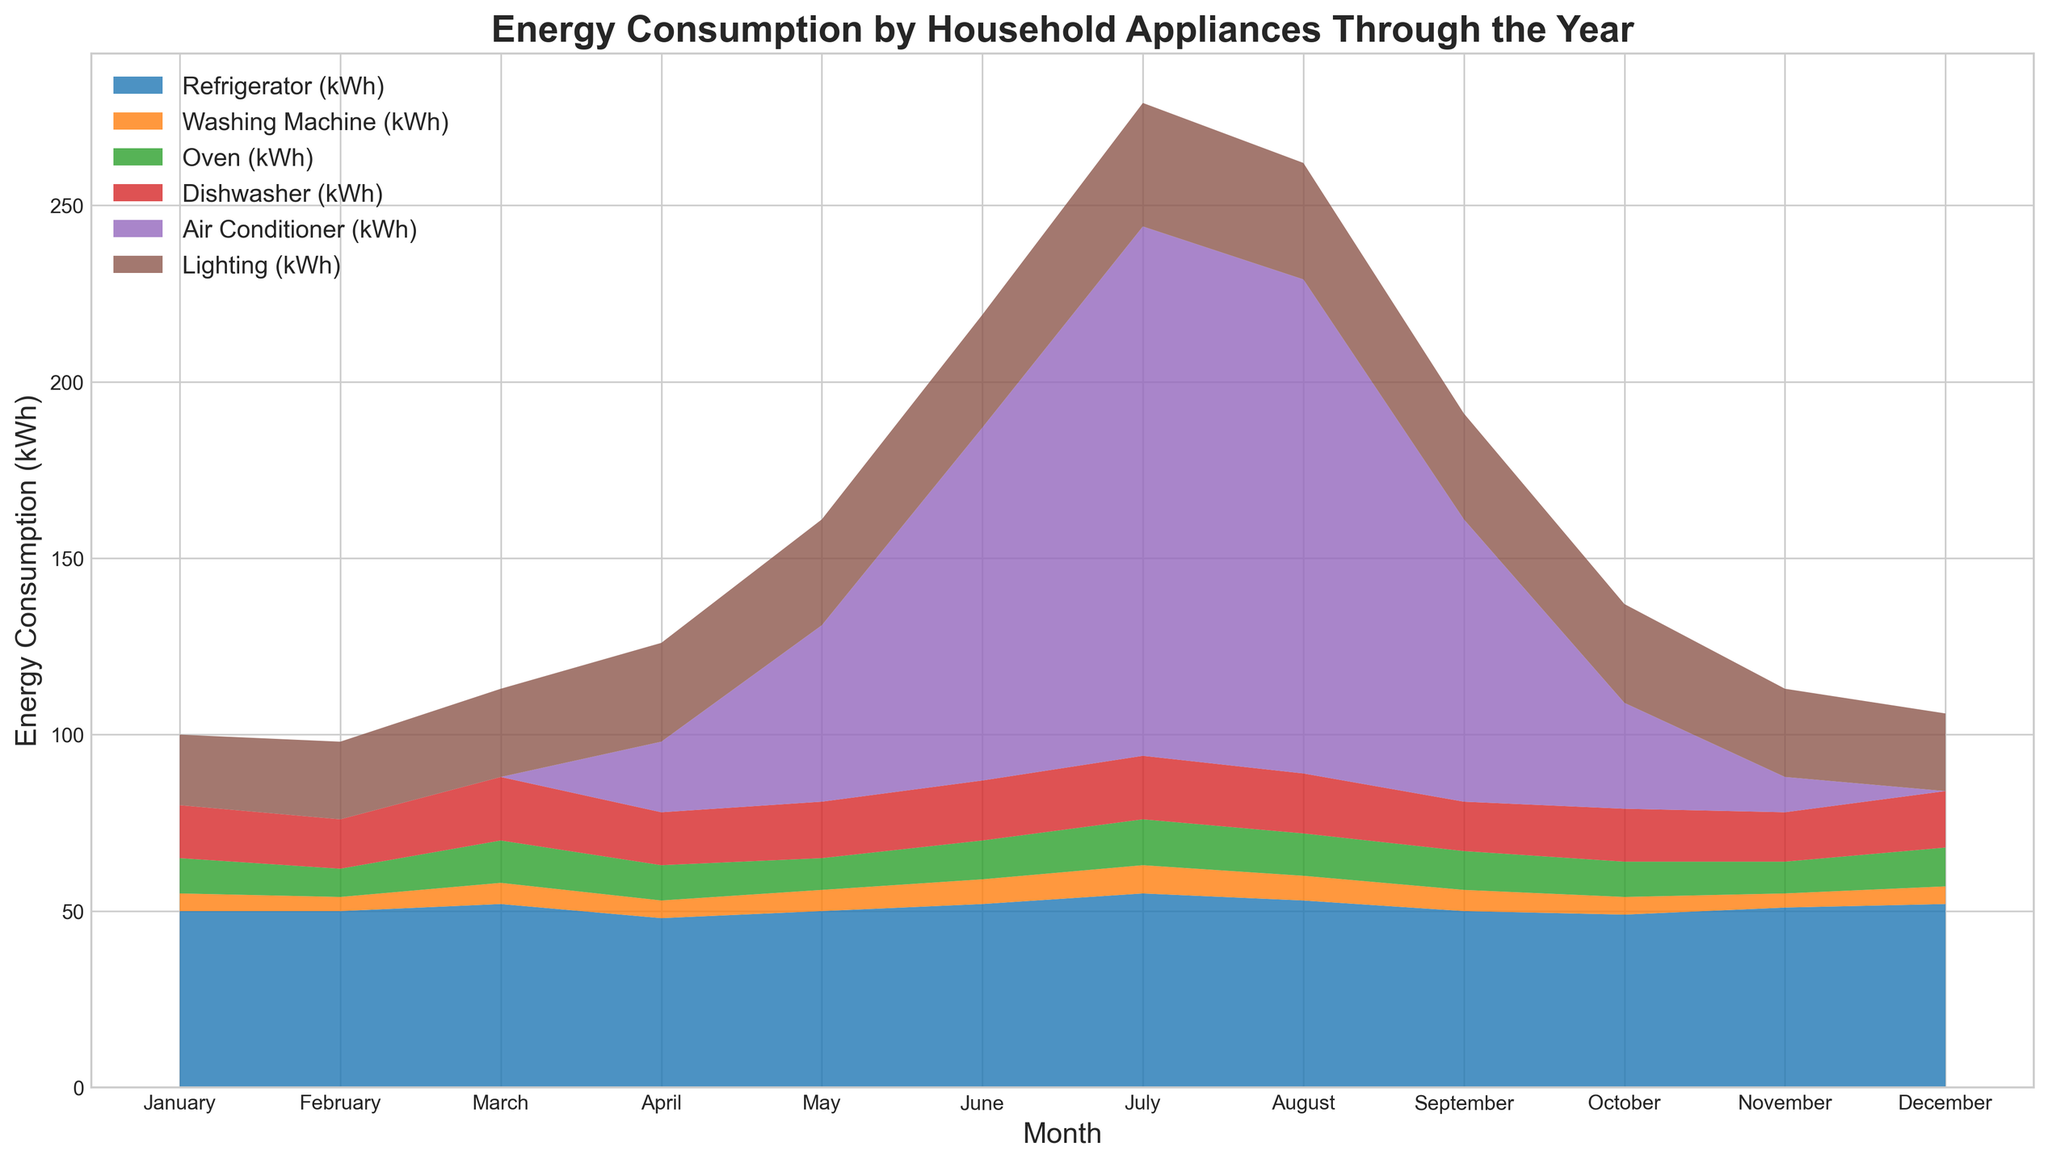What month had the highest total energy consumption? To identify the month with the highest total energy consumption, we sum the energy consumption of all appliances for each month and compare the totals. July has the highest total.
Answer: July Which appliance has the most consistent energy consumption throughout the year? By visual inspection, the Refrigerator's area (color) remains relatively constant in height across all months.
Answer: Refrigerator During which month does the Air Conditioner show a significant increase in energy consumption compared to the previous month? By observing the chart, the Air Conditioner's consumption jumps significantly from May to June, and from June to July as well. The first occurrence is May to June.
Answer: June What is the total energy consumption for the Refrigerator and Lighting in December? Summing the energy consumption: Refrigerator (52 kWh) + Lighting (22 kWh) = 74 kWh.
Answer: 74 kWh Which appliance shows a peak consumption during the mid-year months (June, July, August)? The Air Conditioner's area (color) is at its peak during June, July, and August.
Answer: Air Conditioner Compare the energy consumption of the Oven in January and July. Which month has higher consumption? By observing the heights of the areas corresponding to the Oven's color in January (10 kWh) and July (13 kWh), July has higher consumption.
Answer: July In which month does the energy consumption for the Dishwasher reach its lowest value? The lowest value for the Dishwasher is in February with consumption at 14 kWh.
Answer: February Which two appliances combined have the highest energy consumption in June? By analyzing the height of the stacked areas, Air Conditioner (100 kWh) and Lighting (32 kWh) together have the highest combined total in June.
Answer: Air Conditioner and Lighting How does the total energy consumption in January compare to December? Is it higher, lower, or equal? Summing up all appliances: January (50+5+10+15+0+20 = 100 kWh), December (52+5+11+16+0+22 = 106 kWh). December is higher.
Answer: December is higher Calculate the average energy consumption of the Washing Machine over the year. Summing all monthly values for the Washing Machine (5+4+6+5+6+7+8+7+6+5+4+5 = 68 kWh), then dividing by 12 months, the average is 68/12 ≈ 5.67 kWh.
Answer: 5.67 kWh 